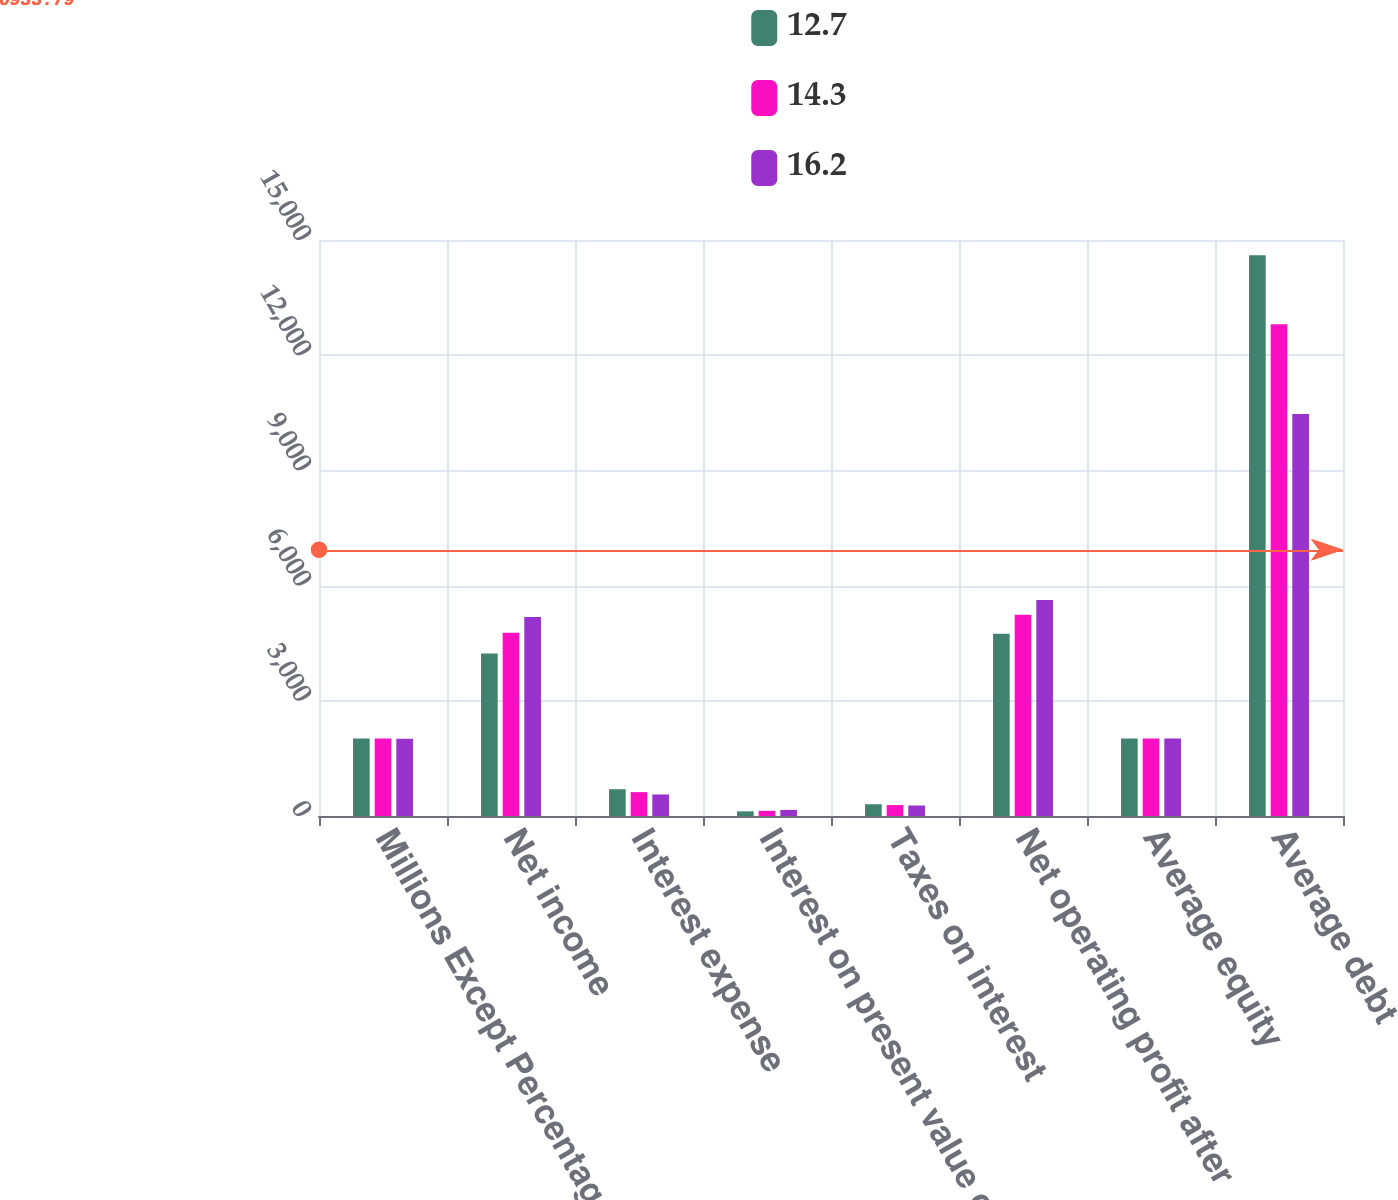Convert chart to OTSL. <chart><loc_0><loc_0><loc_500><loc_500><stacked_bar_chart><ecel><fcel>Millions Except Percentages<fcel>Net income<fcel>Interest expense<fcel>Interest on present value of<fcel>Taxes on interest<fcel>Net operating profit after<fcel>Average equity<fcel>Average debt<nl><fcel>12.7<fcel>2016<fcel>4233<fcel>698<fcel>121<fcel>306<fcel>4746<fcel>2015<fcel>14604<nl><fcel>14.3<fcel>2015<fcel>4772<fcel>622<fcel>135<fcel>285<fcel>5244<fcel>2015<fcel>12807<nl><fcel>16.2<fcel>2014<fcel>5180<fcel>561<fcel>158<fcel>273<fcel>5626<fcel>2015<fcel>10469<nl></chart> 